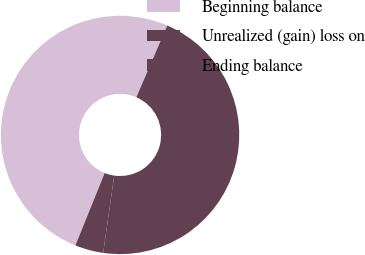Convert chart. <chart><loc_0><loc_0><loc_500><loc_500><pie_chart><fcel>Beginning balance<fcel>Unrealized (gain) loss on<fcel>Ending balance<nl><fcel>50.36%<fcel>3.85%<fcel>45.79%<nl></chart> 